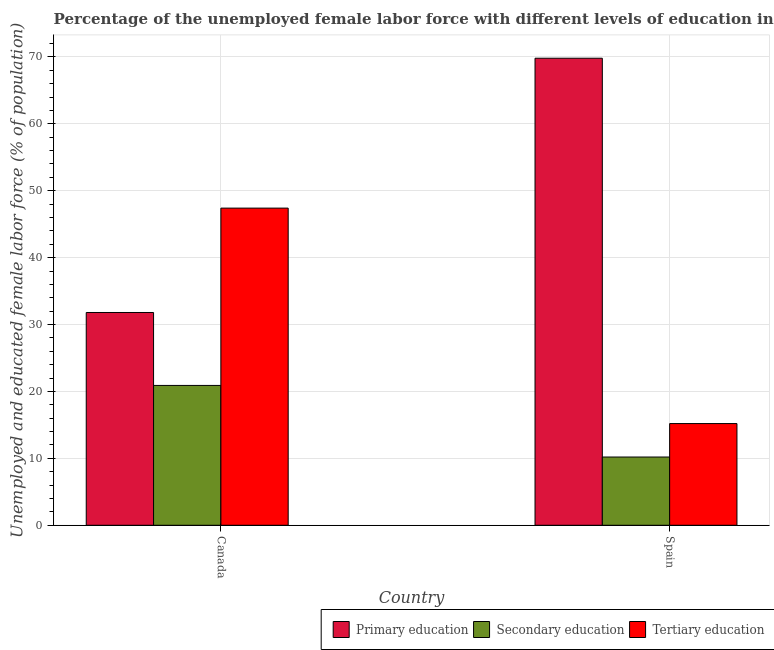How many different coloured bars are there?
Your answer should be very brief. 3. How many groups of bars are there?
Your response must be concise. 2. Are the number of bars per tick equal to the number of legend labels?
Provide a succinct answer. Yes. How many bars are there on the 2nd tick from the right?
Your answer should be compact. 3. What is the label of the 1st group of bars from the left?
Give a very brief answer. Canada. What is the percentage of female labor force who received tertiary education in Canada?
Keep it short and to the point. 47.4. Across all countries, what is the maximum percentage of female labor force who received tertiary education?
Keep it short and to the point. 47.4. Across all countries, what is the minimum percentage of female labor force who received secondary education?
Provide a short and direct response. 10.2. In which country was the percentage of female labor force who received primary education minimum?
Give a very brief answer. Canada. What is the total percentage of female labor force who received tertiary education in the graph?
Your answer should be compact. 62.6. What is the difference between the percentage of female labor force who received primary education in Canada and that in Spain?
Offer a very short reply. -38. What is the difference between the percentage of female labor force who received primary education in Canada and the percentage of female labor force who received secondary education in Spain?
Provide a succinct answer. 21.6. What is the average percentage of female labor force who received primary education per country?
Your answer should be very brief. 50.8. What is the difference between the percentage of female labor force who received secondary education and percentage of female labor force who received primary education in Spain?
Provide a short and direct response. -59.6. In how many countries, is the percentage of female labor force who received primary education greater than 28 %?
Give a very brief answer. 2. What is the ratio of the percentage of female labor force who received tertiary education in Canada to that in Spain?
Provide a succinct answer. 3.12. Is the percentage of female labor force who received primary education in Canada less than that in Spain?
Keep it short and to the point. Yes. What does the 2nd bar from the left in Canada represents?
Offer a terse response. Secondary education. What does the 2nd bar from the right in Canada represents?
Provide a short and direct response. Secondary education. Is it the case that in every country, the sum of the percentage of female labor force who received primary education and percentage of female labor force who received secondary education is greater than the percentage of female labor force who received tertiary education?
Your response must be concise. Yes. How many bars are there?
Your answer should be compact. 6. How many countries are there in the graph?
Your answer should be very brief. 2. What is the difference between two consecutive major ticks on the Y-axis?
Your response must be concise. 10. Are the values on the major ticks of Y-axis written in scientific E-notation?
Provide a succinct answer. No. Does the graph contain grids?
Your answer should be compact. Yes. Where does the legend appear in the graph?
Give a very brief answer. Bottom right. How are the legend labels stacked?
Provide a short and direct response. Horizontal. What is the title of the graph?
Your response must be concise. Percentage of the unemployed female labor force with different levels of education in countries. What is the label or title of the X-axis?
Your answer should be very brief. Country. What is the label or title of the Y-axis?
Your answer should be very brief. Unemployed and educated female labor force (% of population). What is the Unemployed and educated female labor force (% of population) of Primary education in Canada?
Give a very brief answer. 31.8. What is the Unemployed and educated female labor force (% of population) in Secondary education in Canada?
Your answer should be compact. 20.9. What is the Unemployed and educated female labor force (% of population) of Tertiary education in Canada?
Your response must be concise. 47.4. What is the Unemployed and educated female labor force (% of population) of Primary education in Spain?
Make the answer very short. 69.8. What is the Unemployed and educated female labor force (% of population) of Secondary education in Spain?
Keep it short and to the point. 10.2. What is the Unemployed and educated female labor force (% of population) of Tertiary education in Spain?
Your answer should be very brief. 15.2. Across all countries, what is the maximum Unemployed and educated female labor force (% of population) in Primary education?
Offer a very short reply. 69.8. Across all countries, what is the maximum Unemployed and educated female labor force (% of population) in Secondary education?
Your answer should be very brief. 20.9. Across all countries, what is the maximum Unemployed and educated female labor force (% of population) of Tertiary education?
Your answer should be very brief. 47.4. Across all countries, what is the minimum Unemployed and educated female labor force (% of population) in Primary education?
Keep it short and to the point. 31.8. Across all countries, what is the minimum Unemployed and educated female labor force (% of population) of Secondary education?
Give a very brief answer. 10.2. Across all countries, what is the minimum Unemployed and educated female labor force (% of population) in Tertiary education?
Offer a very short reply. 15.2. What is the total Unemployed and educated female labor force (% of population) of Primary education in the graph?
Your answer should be compact. 101.6. What is the total Unemployed and educated female labor force (% of population) in Secondary education in the graph?
Give a very brief answer. 31.1. What is the total Unemployed and educated female labor force (% of population) in Tertiary education in the graph?
Provide a succinct answer. 62.6. What is the difference between the Unemployed and educated female labor force (% of population) in Primary education in Canada and that in Spain?
Your response must be concise. -38. What is the difference between the Unemployed and educated female labor force (% of population) in Tertiary education in Canada and that in Spain?
Your answer should be compact. 32.2. What is the difference between the Unemployed and educated female labor force (% of population) in Primary education in Canada and the Unemployed and educated female labor force (% of population) in Secondary education in Spain?
Ensure brevity in your answer.  21.6. What is the average Unemployed and educated female labor force (% of population) in Primary education per country?
Offer a terse response. 50.8. What is the average Unemployed and educated female labor force (% of population) of Secondary education per country?
Give a very brief answer. 15.55. What is the average Unemployed and educated female labor force (% of population) in Tertiary education per country?
Provide a short and direct response. 31.3. What is the difference between the Unemployed and educated female labor force (% of population) of Primary education and Unemployed and educated female labor force (% of population) of Secondary education in Canada?
Ensure brevity in your answer.  10.9. What is the difference between the Unemployed and educated female labor force (% of population) in Primary education and Unemployed and educated female labor force (% of population) in Tertiary education in Canada?
Keep it short and to the point. -15.6. What is the difference between the Unemployed and educated female labor force (% of population) of Secondary education and Unemployed and educated female labor force (% of population) of Tertiary education in Canada?
Offer a terse response. -26.5. What is the difference between the Unemployed and educated female labor force (% of population) of Primary education and Unemployed and educated female labor force (% of population) of Secondary education in Spain?
Give a very brief answer. 59.6. What is the difference between the Unemployed and educated female labor force (% of population) of Primary education and Unemployed and educated female labor force (% of population) of Tertiary education in Spain?
Make the answer very short. 54.6. What is the difference between the Unemployed and educated female labor force (% of population) of Secondary education and Unemployed and educated female labor force (% of population) of Tertiary education in Spain?
Ensure brevity in your answer.  -5. What is the ratio of the Unemployed and educated female labor force (% of population) of Primary education in Canada to that in Spain?
Give a very brief answer. 0.46. What is the ratio of the Unemployed and educated female labor force (% of population) in Secondary education in Canada to that in Spain?
Provide a short and direct response. 2.05. What is the ratio of the Unemployed and educated female labor force (% of population) in Tertiary education in Canada to that in Spain?
Give a very brief answer. 3.12. What is the difference between the highest and the second highest Unemployed and educated female labor force (% of population) in Tertiary education?
Offer a terse response. 32.2. What is the difference between the highest and the lowest Unemployed and educated female labor force (% of population) of Tertiary education?
Keep it short and to the point. 32.2. 